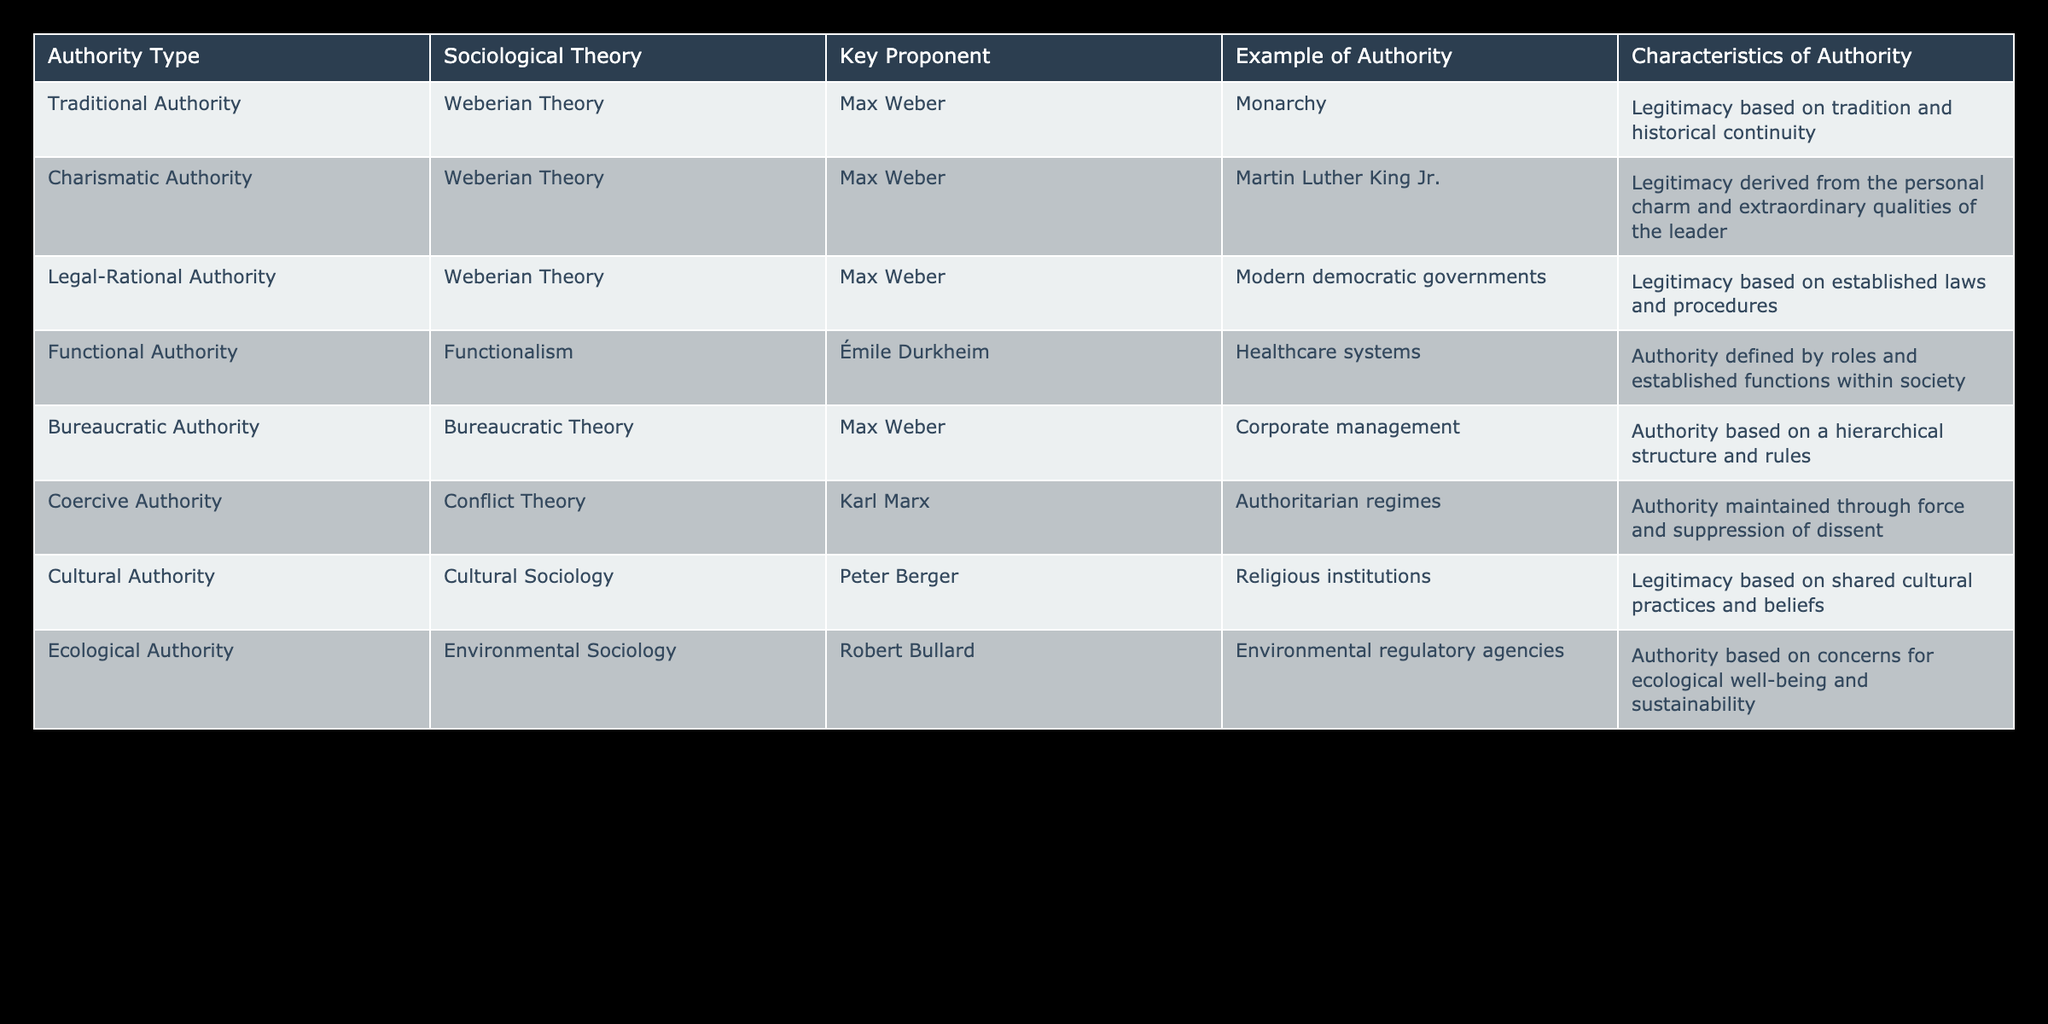What are the three types of authority proposed by Max Weber? According to the table, Max Weber proposed three types of authority: Traditional Authority, Charismatic Authority, and Legal-Rational Authority.
Answer: Traditional Authority, Charismatic Authority, Legal-Rational Authority Which authority type is associated with Émile Durkheim? The authority type associated with Émile Durkheim is Functional Authority, as mentioned in the table.
Answer: Functional Authority Is Charismatic Authority based on historical continuity? No, Charismatic Authority is based on personal charm and extraordinary qualities of the leader, not on historical continuity which is characteristic of Traditional Authority.
Answer: No What example of authority is illustrated under Legal-Rational Authority? The example of authority illustrated under Legal-Rational Authority is modern democratic governments, as stated in the table.
Answer: Modern democratic governments What is the main characteristic of Bureaucratic Authority, according to the table? The main characteristic of Bureaucratic Authority, according to the table, is that it is based on a hierarchical structure and rules.
Answer: Hierarchical structure and rules How many types of authority listed in the table are derived from sociological theories outside of Weberian Theory? There are three types of authority derived from sociological theories outside of Weberian Theory: Functional Authority, Coercive Authority, and Cultural Authority.
Answer: Three If we combine the numbers of the sociological theories based on authority types, how many are related to "Authority"? There are six types of authority listed in the table: Traditional, Charismatic, Legal-Rational, Functional, Bureaucratic, and Coercive. The total number is six.
Answer: Six Which authority type has an example of Martin Luther King Jr. as its key figure? The authority type that has Martin Luther King Jr. as its key figure is Charismatic Authority.
Answer: Charismatic Authority What type of authority is characterized by the suppression of dissent? The type of authority characterized by the suppression of dissent is Coercive Authority, as it is maintained through force.
Answer: Coercive Authority 